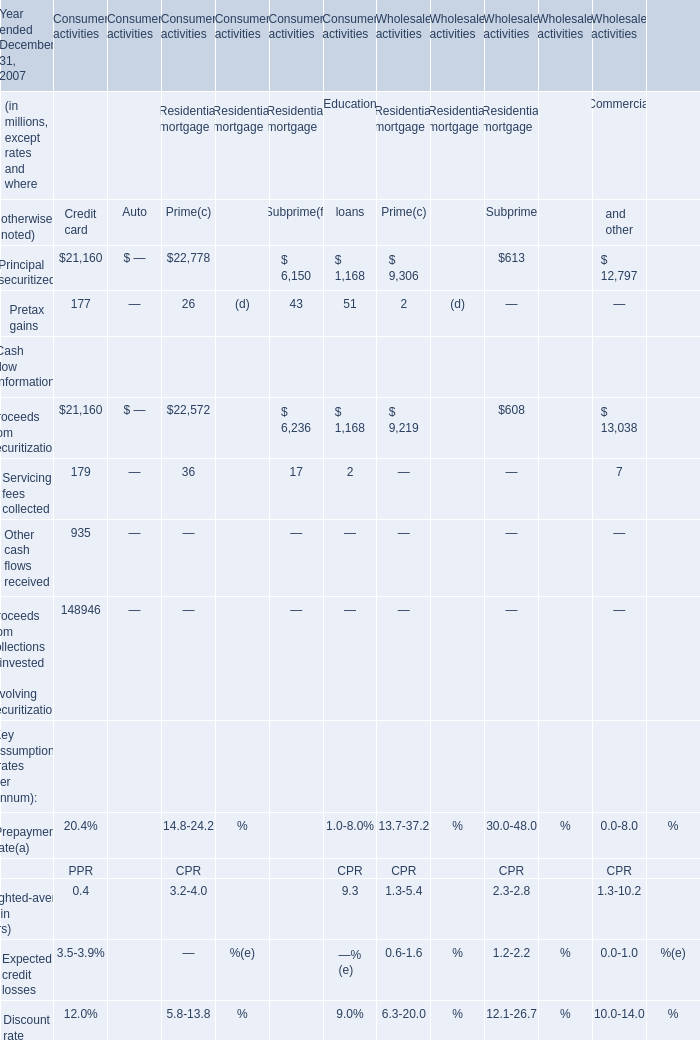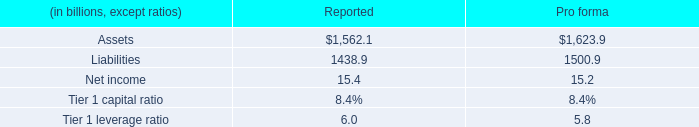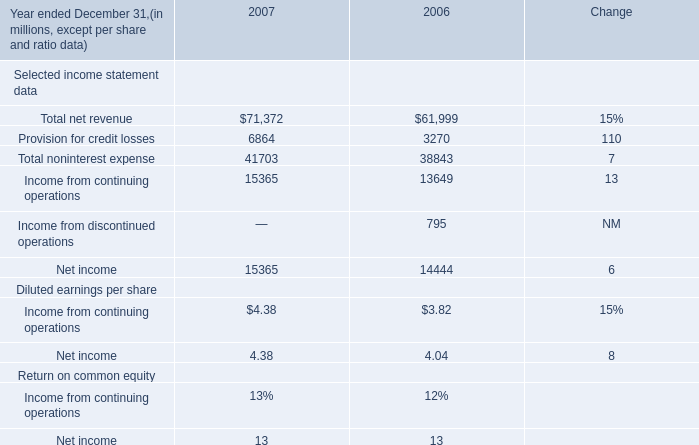what is the average assets ( in billions ) for each of the firm's self sponsored conduits? 
Computations: (1562.1 / 4)
Answer: 390.525. 